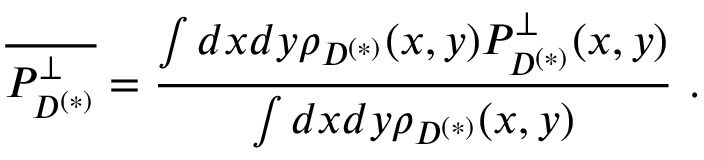Convert formula to latex. <formula><loc_0><loc_0><loc_500><loc_500>\overline { { { P _ { D ^ { ( * ) } } ^ { \perp } } } } = \frac { \int d x d y \rho _ { D ^ { ( * ) } } ( x , y ) P _ { D ^ { ( * ) } } ^ { \perp } ( x , y ) } { \int d x d y \rho _ { D ^ { ( * ) } } ( x , y ) } .</formula> 